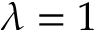<formula> <loc_0><loc_0><loc_500><loc_500>\lambda = 1</formula> 